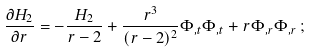<formula> <loc_0><loc_0><loc_500><loc_500>\frac { \partial H _ { 2 } } { \partial r } = - \frac { H _ { 2 } } { r - 2 } + \frac { r ^ { 3 } } { ( r - 2 ) ^ { 2 } } \Phi _ { , t } \Phi _ { , t } + r \Phi _ { , r } \Phi _ { , r } \, ;</formula> 